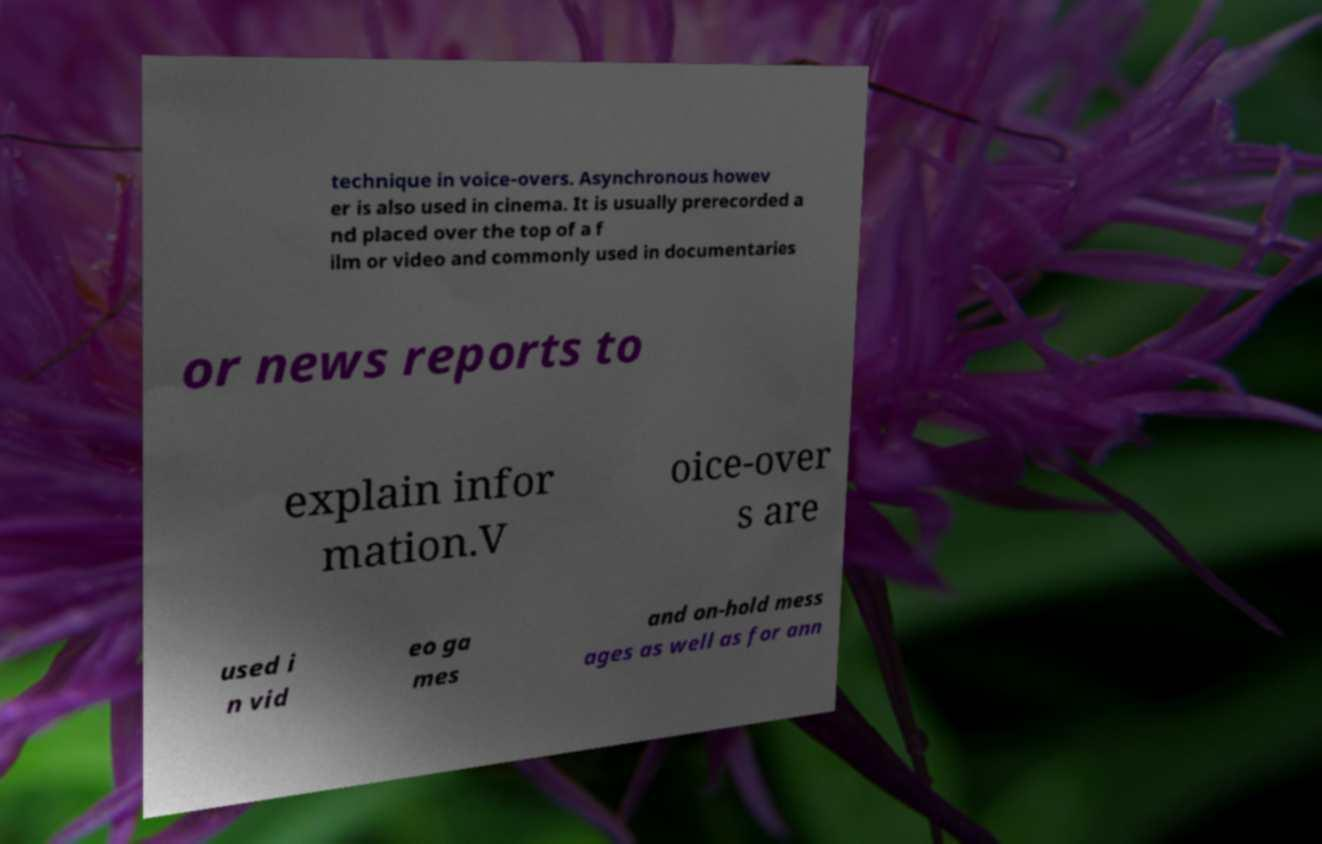For documentation purposes, I need the text within this image transcribed. Could you provide that? technique in voice-overs. Asynchronous howev er is also used in cinema. It is usually prerecorded a nd placed over the top of a f ilm or video and commonly used in documentaries or news reports to explain infor mation.V oice-over s are used i n vid eo ga mes and on-hold mess ages as well as for ann 